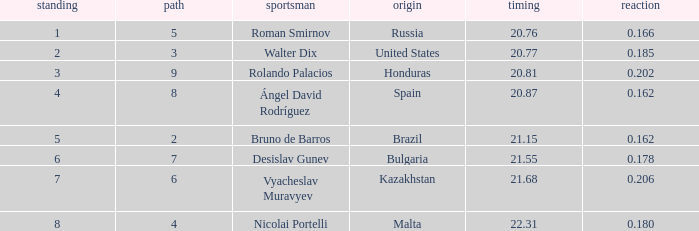What's Bulgaria's lane with a time more than 21.55? None. 